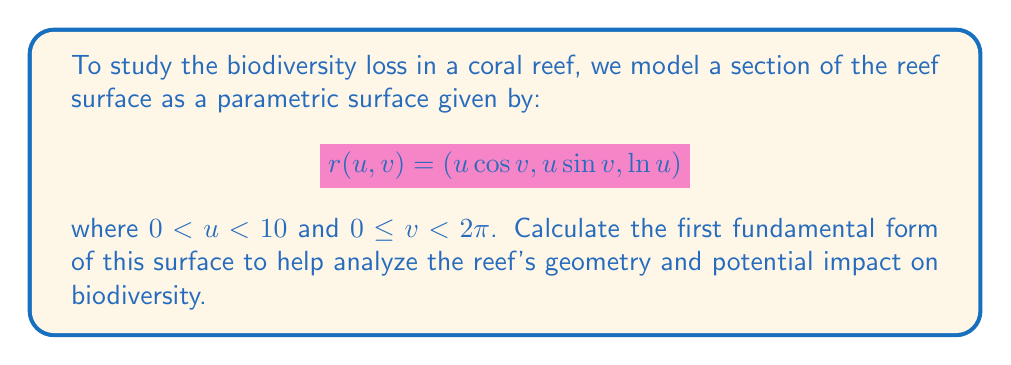Show me your answer to this math problem. To calculate the first fundamental form, we need to follow these steps:

1) The first fundamental form is given by:
   $$I = Edu^2 + 2Fdudv + Gdv^2$$
   where $E = r_u \cdot r_u$, $F = r_u \cdot r_v$, and $G = r_v \cdot r_v$

2) First, let's calculate $r_u$ and $r_v$:
   $$r_u = (\cos v, \sin v, \frac{1}{u})$$
   $$r_v = (-u\sin v, u\cos v, 0)$$

3) Now, we can calculate E:
   $$E = r_u \cdot r_u = \cos^2 v + \sin^2 v + \frac{1}{u^2} = 1 + \frac{1}{u^2}$$

4) Next, let's calculate F:
   $$F = r_u \cdot r_v = -u\sin v \cos v + u\sin v \cos v + 0 = 0$$

5) Finally, we calculate G:
   $$G = r_v \cdot r_v = u^2\sin^2 v + u^2\cos^2 v = u^2$$

6) Substituting these values into the first fundamental form:
   $$I = (1 + \frac{1}{u^2})du^2 + u^2dv^2$$

This form allows us to analyze the local geometry of the coral reef surface, which is crucial for understanding how changes in the reef's structure might affect biodiversity.
Answer: $$I = (1 + \frac{1}{u^2})du^2 + u^2dv^2$$ 